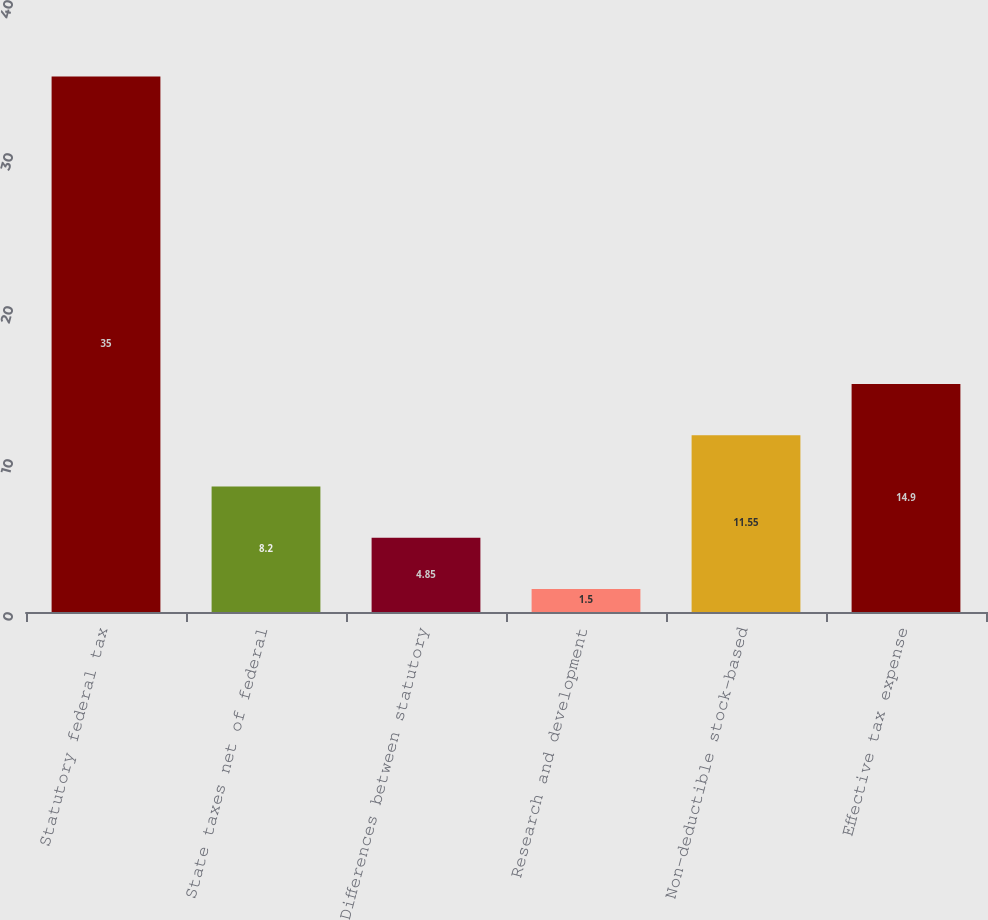Convert chart. <chart><loc_0><loc_0><loc_500><loc_500><bar_chart><fcel>Statutory federal tax<fcel>State taxes net of federal<fcel>Differences between statutory<fcel>Research and development<fcel>Non-deductible stock-based<fcel>Effective tax expense<nl><fcel>35<fcel>8.2<fcel>4.85<fcel>1.5<fcel>11.55<fcel>14.9<nl></chart> 